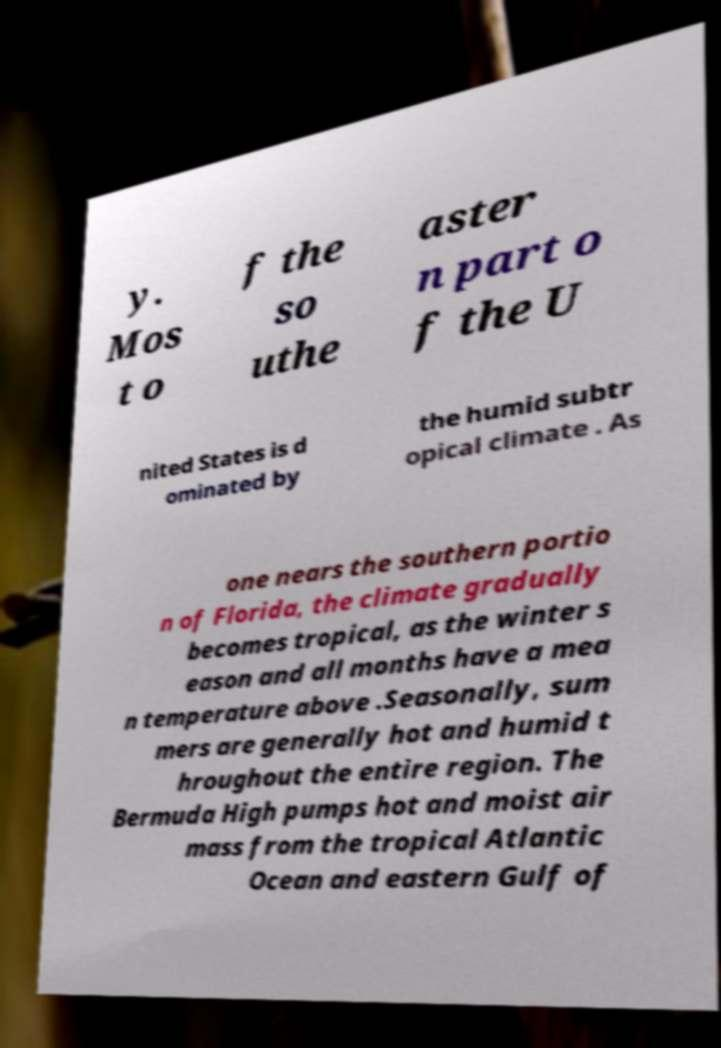Can you read and provide the text displayed in the image?This photo seems to have some interesting text. Can you extract and type it out for me? y. Mos t o f the so uthe aster n part o f the U nited States is d ominated by the humid subtr opical climate . As one nears the southern portio n of Florida, the climate gradually becomes tropical, as the winter s eason and all months have a mea n temperature above .Seasonally, sum mers are generally hot and humid t hroughout the entire region. The Bermuda High pumps hot and moist air mass from the tropical Atlantic Ocean and eastern Gulf of 